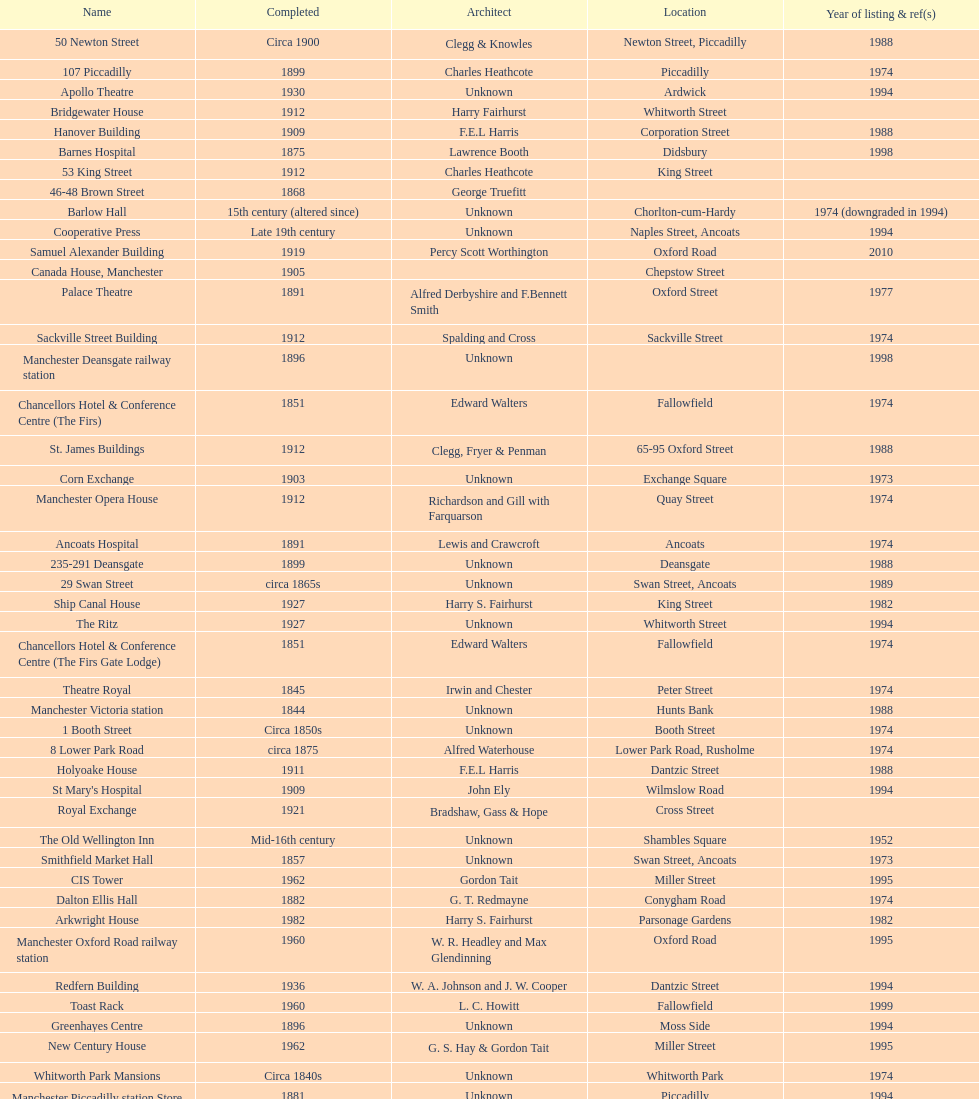What is the difference, in years, between the completion dates of 53 king street and castlefield congregational chapel? 54 years. 